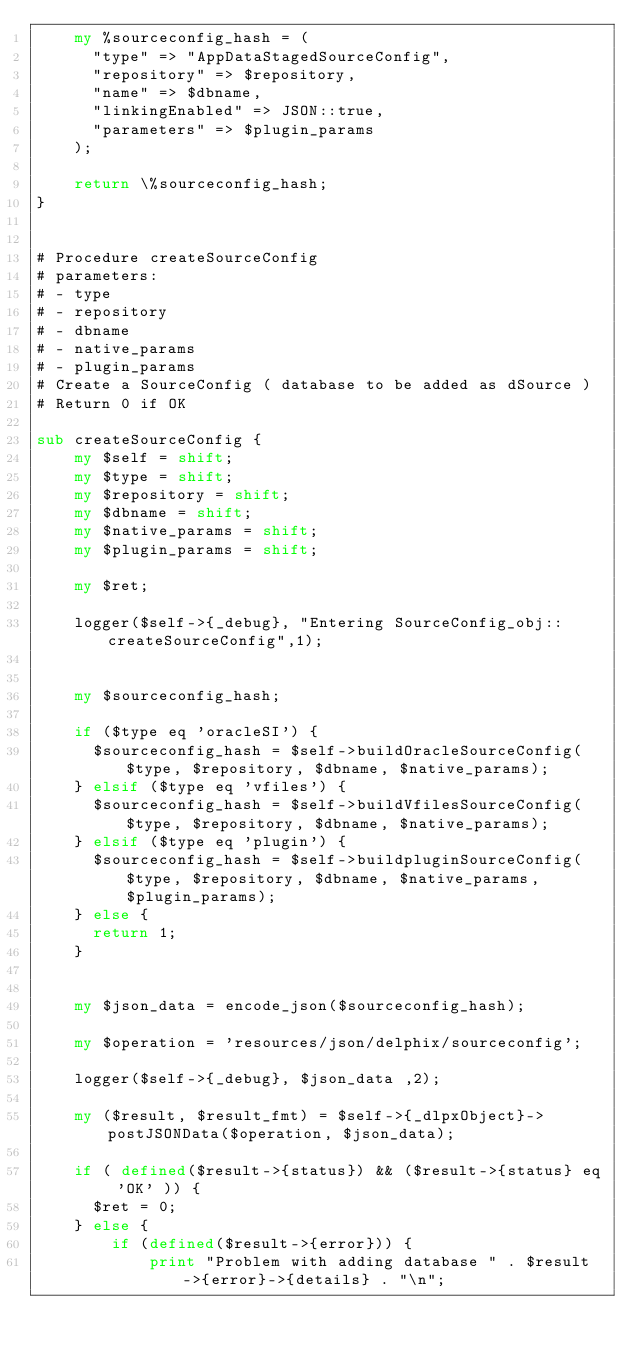<code> <loc_0><loc_0><loc_500><loc_500><_Perl_>    my %sourceconfig_hash = (
      "type" => "AppDataStagedSourceConfig",
      "repository" => $repository,
      "name" => $dbname,
      "linkingEnabled" => JSON::true,
      "parameters" => $plugin_params
    );

    return \%sourceconfig_hash;
}


# Procedure createSourceConfig
# parameters:
# - type
# - repository
# - dbname
# - native_params
# - plugin_params
# Create a SourceConfig ( database to be added as dSource )
# Return 0 if OK

sub createSourceConfig {
    my $self = shift;
    my $type = shift;
    my $repository = shift;
    my $dbname = shift;
    my $native_params = shift;
    my $plugin_params = shift;

    my $ret;

    logger($self->{_debug}, "Entering SourceConfig_obj::createSourceConfig",1);


    my $sourceconfig_hash;

    if ($type eq 'oracleSI') {
      $sourceconfig_hash = $self->buildOracleSourceConfig($type, $repository, $dbname, $native_params);
    } elsif ($type eq 'vfiles') {
      $sourceconfig_hash = $self->buildVfilesSourceConfig($type, $repository, $dbname, $native_params);
    } elsif ($type eq 'plugin') {
      $sourceconfig_hash = $self->buildpluginSourceConfig($type, $repository, $dbname, $native_params, $plugin_params);
    } else {
      return 1;
    }


    my $json_data = encode_json($sourceconfig_hash);

    my $operation = 'resources/json/delphix/sourceconfig';

    logger($self->{_debug}, $json_data ,2);

    my ($result, $result_fmt) = $self->{_dlpxObject}->postJSONData($operation, $json_data);

    if ( defined($result->{status}) && ($result->{status} eq 'OK' )) {
      $ret = 0;
    } else {
        if (defined($result->{error})) {
            print "Problem with adding database " . $result->{error}->{details} . "\n";</code> 